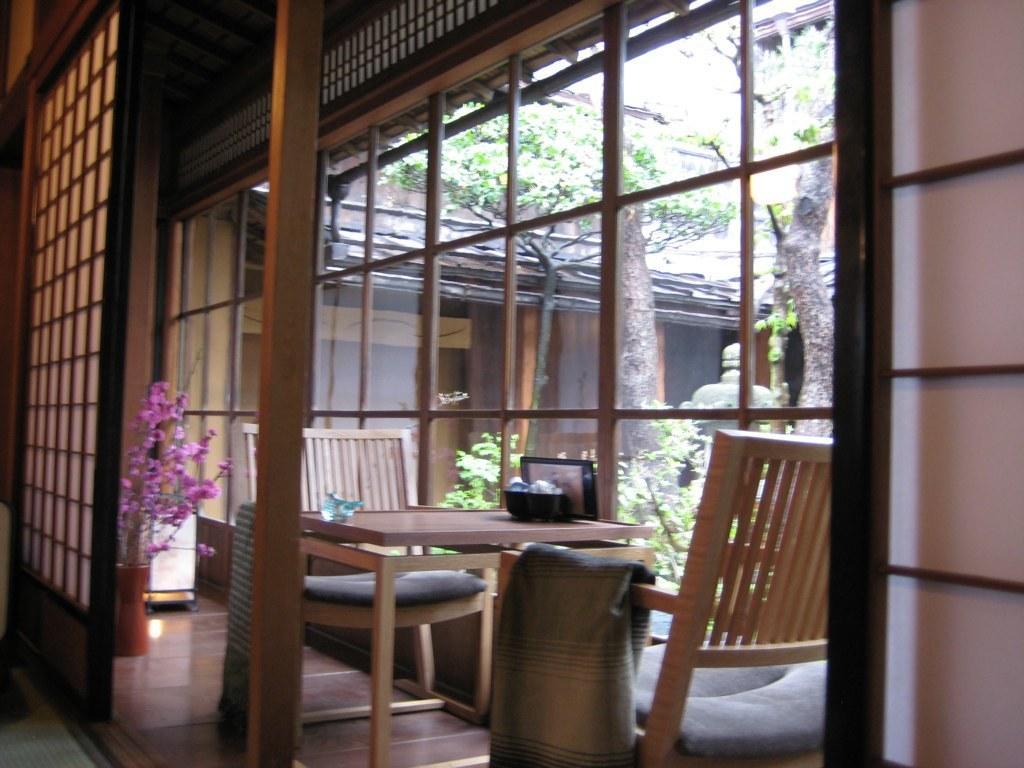In one or two sentences, can you explain what this image depicts? In the picture I can see wooden table and chairs, flower vase, pillars, trees and wooden house. 